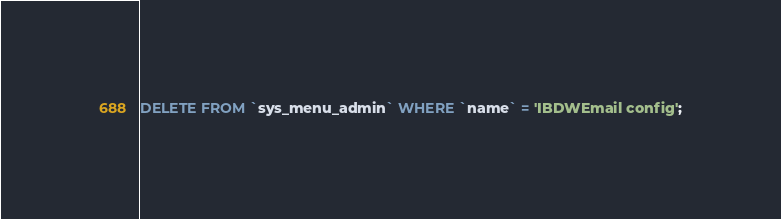<code> <loc_0><loc_0><loc_500><loc_500><_SQL_>DELETE FROM `sys_menu_admin` WHERE `name` = 'IBDWEmail config';</code> 